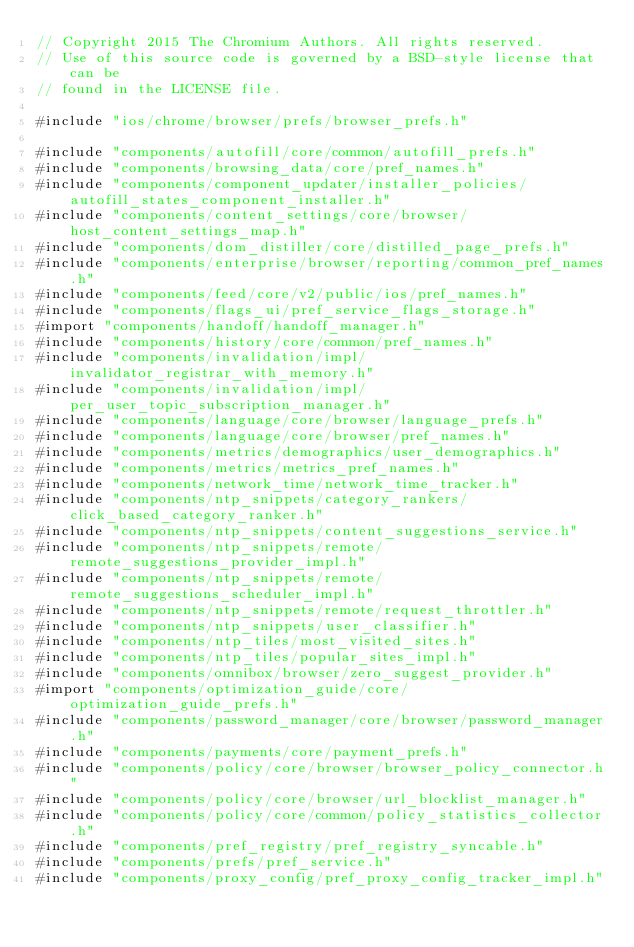<code> <loc_0><loc_0><loc_500><loc_500><_ObjectiveC_>// Copyright 2015 The Chromium Authors. All rights reserved.
// Use of this source code is governed by a BSD-style license that can be
// found in the LICENSE file.

#include "ios/chrome/browser/prefs/browser_prefs.h"

#include "components/autofill/core/common/autofill_prefs.h"
#include "components/browsing_data/core/pref_names.h"
#include "components/component_updater/installer_policies/autofill_states_component_installer.h"
#include "components/content_settings/core/browser/host_content_settings_map.h"
#include "components/dom_distiller/core/distilled_page_prefs.h"
#include "components/enterprise/browser/reporting/common_pref_names.h"
#include "components/feed/core/v2/public/ios/pref_names.h"
#include "components/flags_ui/pref_service_flags_storage.h"
#import "components/handoff/handoff_manager.h"
#include "components/history/core/common/pref_names.h"
#include "components/invalidation/impl/invalidator_registrar_with_memory.h"
#include "components/invalidation/impl/per_user_topic_subscription_manager.h"
#include "components/language/core/browser/language_prefs.h"
#include "components/language/core/browser/pref_names.h"
#include "components/metrics/demographics/user_demographics.h"
#include "components/metrics/metrics_pref_names.h"
#include "components/network_time/network_time_tracker.h"
#include "components/ntp_snippets/category_rankers/click_based_category_ranker.h"
#include "components/ntp_snippets/content_suggestions_service.h"
#include "components/ntp_snippets/remote/remote_suggestions_provider_impl.h"
#include "components/ntp_snippets/remote/remote_suggestions_scheduler_impl.h"
#include "components/ntp_snippets/remote/request_throttler.h"
#include "components/ntp_snippets/user_classifier.h"
#include "components/ntp_tiles/most_visited_sites.h"
#include "components/ntp_tiles/popular_sites_impl.h"
#include "components/omnibox/browser/zero_suggest_provider.h"
#import "components/optimization_guide/core/optimization_guide_prefs.h"
#include "components/password_manager/core/browser/password_manager.h"
#include "components/payments/core/payment_prefs.h"
#include "components/policy/core/browser/browser_policy_connector.h"
#include "components/policy/core/browser/url_blocklist_manager.h"
#include "components/policy/core/common/policy_statistics_collector.h"
#include "components/pref_registry/pref_registry_syncable.h"
#include "components/prefs/pref_service.h"
#include "components/proxy_config/pref_proxy_config_tracker_impl.h"</code> 